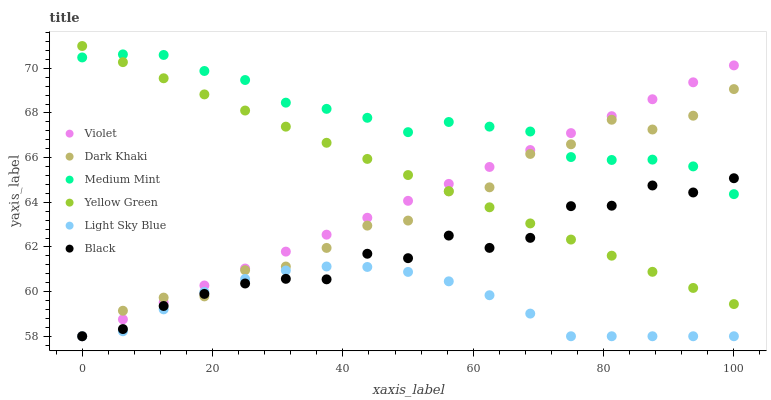Does Light Sky Blue have the minimum area under the curve?
Answer yes or no. Yes. Does Medium Mint have the maximum area under the curve?
Answer yes or no. Yes. Does Yellow Green have the minimum area under the curve?
Answer yes or no. No. Does Yellow Green have the maximum area under the curve?
Answer yes or no. No. Is Yellow Green the smoothest?
Answer yes or no. Yes. Is Black the roughest?
Answer yes or no. Yes. Is Dark Khaki the smoothest?
Answer yes or no. No. Is Dark Khaki the roughest?
Answer yes or no. No. Does Dark Khaki have the lowest value?
Answer yes or no. Yes. Does Yellow Green have the lowest value?
Answer yes or no. No. Does Yellow Green have the highest value?
Answer yes or no. Yes. Does Dark Khaki have the highest value?
Answer yes or no. No. Is Light Sky Blue less than Yellow Green?
Answer yes or no. Yes. Is Medium Mint greater than Light Sky Blue?
Answer yes or no. Yes. Does Black intersect Violet?
Answer yes or no. Yes. Is Black less than Violet?
Answer yes or no. No. Is Black greater than Violet?
Answer yes or no. No. Does Light Sky Blue intersect Yellow Green?
Answer yes or no. No. 